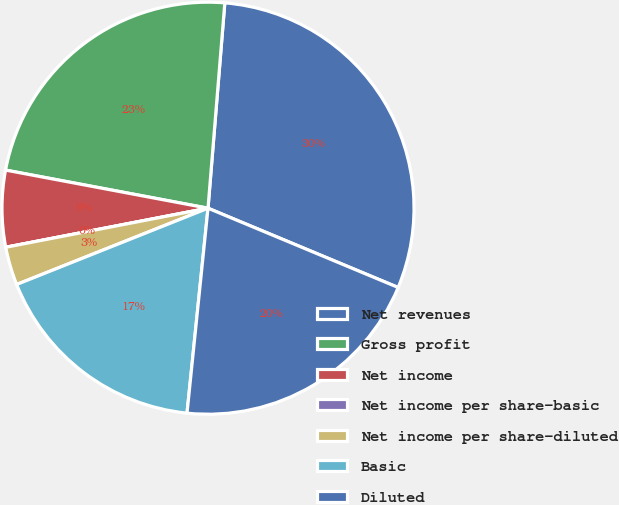Convert chart to OTSL. <chart><loc_0><loc_0><loc_500><loc_500><pie_chart><fcel>Net revenues<fcel>Gross profit<fcel>Net income<fcel>Net income per share-basic<fcel>Net income per share-diluted<fcel>Basic<fcel>Diluted<nl><fcel>29.99%<fcel>23.34%<fcel>6.0%<fcel>0.0%<fcel>3.0%<fcel>17.34%<fcel>20.34%<nl></chart> 